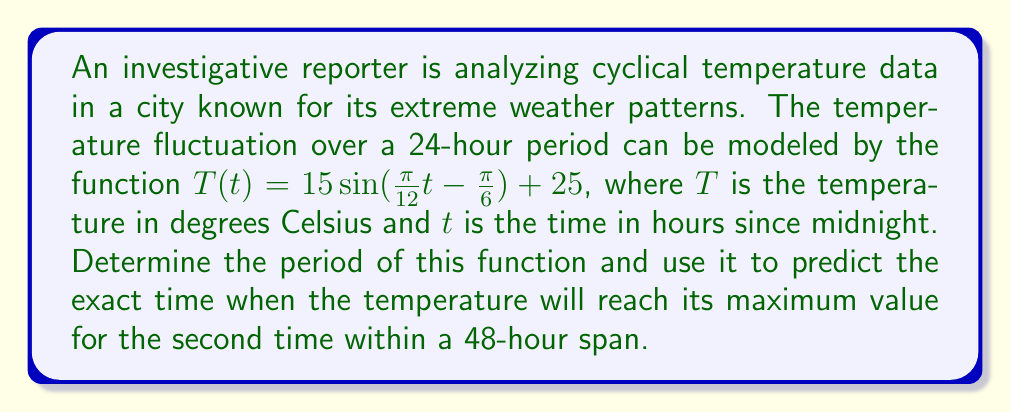Show me your answer to this math problem. 1. To find the period of the function, we need to analyze the coefficient of $t$ inside the sine function. The general form of a sine function is $\sin(Bt + C)$, where $B = \frac{2\pi}{P}$ and $P$ is the period.

2. In our function, $B = \frac{\pi}{12}$. So:

   $\frac{\pi}{12} = \frac{2\pi}{P}$

3. Solving for $P$:
   
   $P = \frac{2\pi}{\frac{\pi}{12}} = 2\pi \cdot \frac{12}{\pi} = 24$

4. The period is 24 hours, which makes sense for a daily temperature cycle.

5. To find when the temperature reaches its maximum, we need to solve:

   $\frac{\pi}{12}t - \frac{\pi}{6} = \frac{\pi}{2}$ (maximum of sine function)

6. Solving for $t$:

   $\frac{\pi}{12}t = \frac{\pi}{2} + \frac{\pi}{6} = \frac{2\pi}{3}$
   
   $t = \frac{2\pi}{3} \cdot \frac{12}{\pi} = 8$

7. The first maximum occurs at 8:00 AM (8 hours after midnight).

8. Since the period is 24 hours, the second maximum will occur exactly 24 hours later, at 8:00 AM the next day, which is 32 hours after the initial midnight.
Answer: 32 hours 